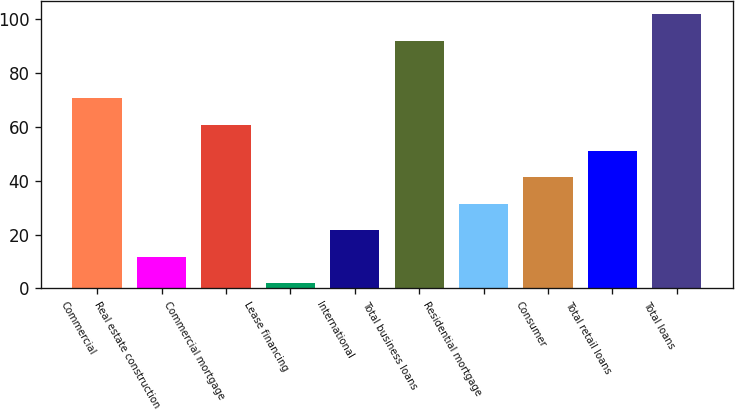Convert chart. <chart><loc_0><loc_0><loc_500><loc_500><bar_chart><fcel>Commercial<fcel>Real estate construction<fcel>Commercial mortgage<fcel>Lease financing<fcel>International<fcel>Total business loans<fcel>Residential mortgage<fcel>Consumer<fcel>Total retail loans<fcel>Total loans<nl><fcel>70.6<fcel>11.8<fcel>60.8<fcel>2<fcel>21.6<fcel>92<fcel>31.4<fcel>41.2<fcel>51<fcel>101.8<nl></chart> 